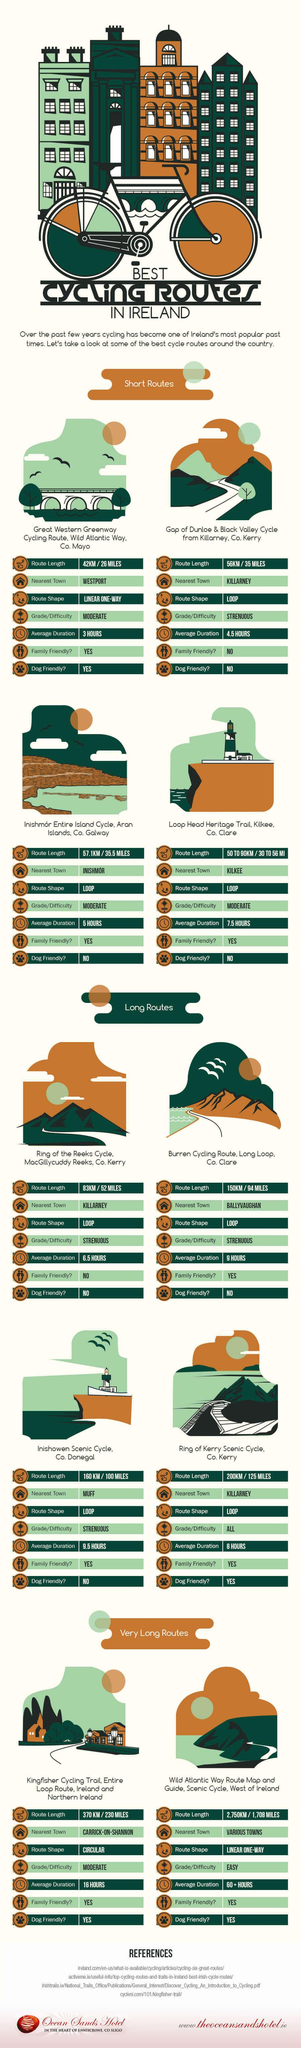Highlight a few significant elements in this photo. The Inishowen Scenic Cycle Route is a long-distance cycling route that takes approximately 9.5 hours to complete. There are a total of 4 dog-friendly routes. The shortest length one can cycle in long cycling routes is 83 kilometers or 52 miles. There are approximately three moderately challenging short cycling routes. The Gap of Dunloe and Black Valley routes are not considered family-friendly in the short routes. 